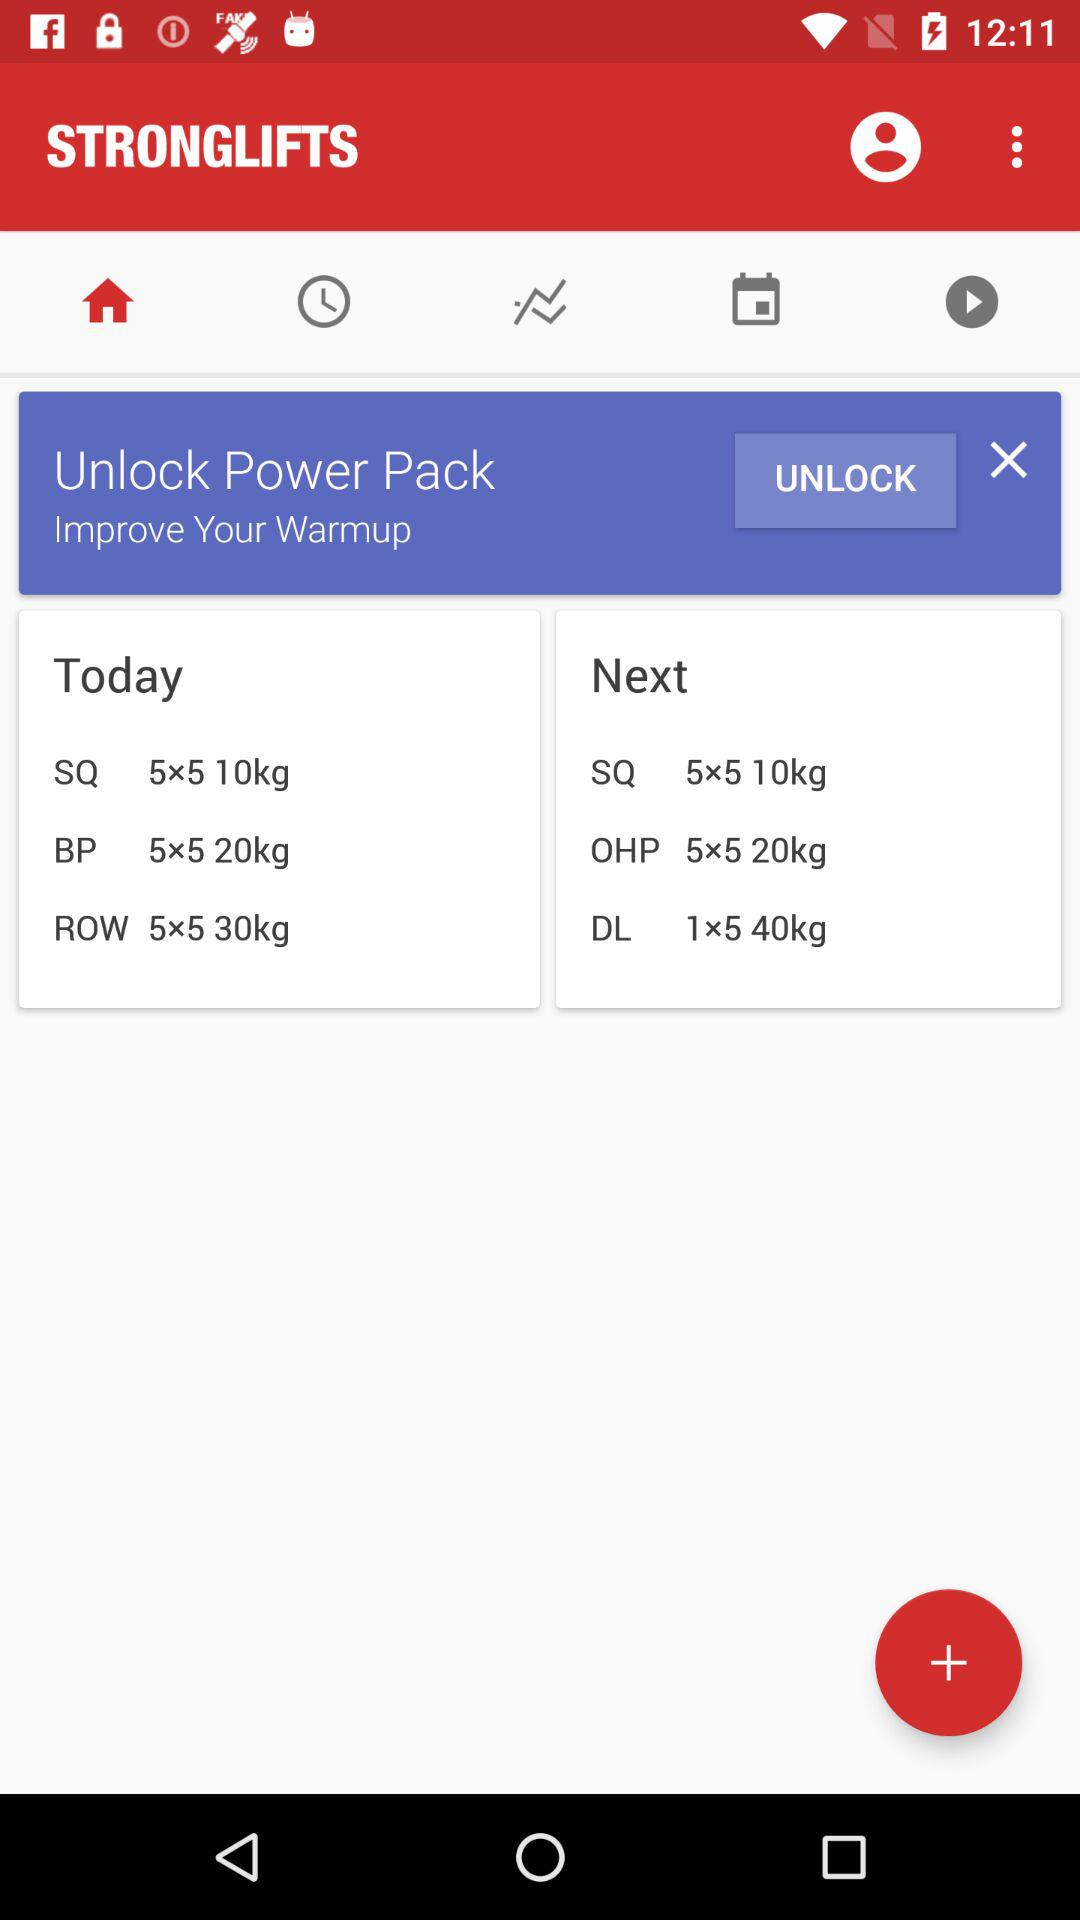How many exercises are there in total?
Answer the question using a single word or phrase. 6 